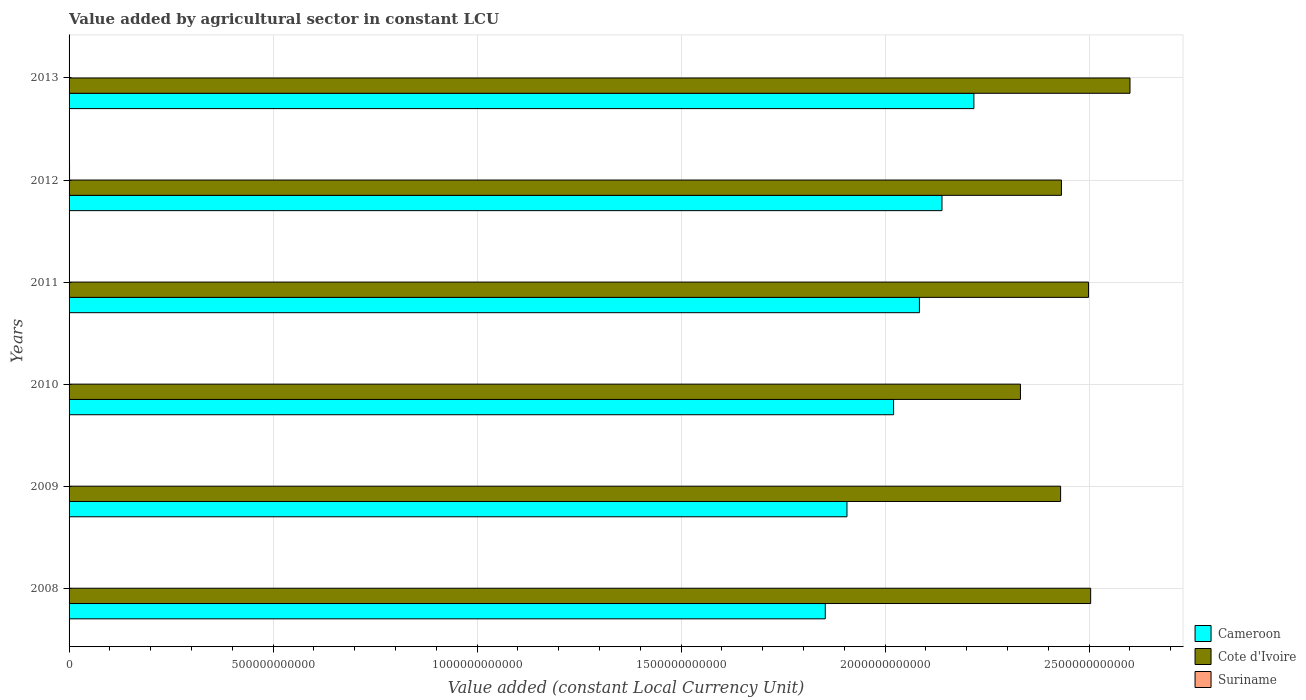How many different coloured bars are there?
Your response must be concise. 3. Are the number of bars per tick equal to the number of legend labels?
Keep it short and to the point. Yes. Are the number of bars on each tick of the Y-axis equal?
Your answer should be compact. Yes. How many bars are there on the 6th tick from the top?
Ensure brevity in your answer.  3. What is the value added by agricultural sector in Cameroon in 2012?
Offer a very short reply. 2.14e+12. Across all years, what is the maximum value added by agricultural sector in Suriname?
Ensure brevity in your answer.  1.17e+09. Across all years, what is the minimum value added by agricultural sector in Cote d'Ivoire?
Give a very brief answer. 2.33e+12. In which year was the value added by agricultural sector in Cameroon minimum?
Provide a short and direct response. 2008. What is the total value added by agricultural sector in Cameroon in the graph?
Offer a terse response. 1.22e+13. What is the difference between the value added by agricultural sector in Cameroon in 2008 and that in 2012?
Ensure brevity in your answer.  -2.86e+11. What is the difference between the value added by agricultural sector in Suriname in 2011 and the value added by agricultural sector in Cameroon in 2008?
Offer a very short reply. -1.85e+12. What is the average value added by agricultural sector in Cote d'Ivoire per year?
Keep it short and to the point. 2.47e+12. In the year 2010, what is the difference between the value added by agricultural sector in Cote d'Ivoire and value added by agricultural sector in Suriname?
Your response must be concise. 2.33e+12. In how many years, is the value added by agricultural sector in Cote d'Ivoire greater than 1800000000000 LCU?
Make the answer very short. 6. What is the ratio of the value added by agricultural sector in Suriname in 2008 to that in 2010?
Offer a terse response. 0.75. Is the value added by agricultural sector in Cameroon in 2010 less than that in 2011?
Offer a very short reply. Yes. Is the difference between the value added by agricultural sector in Cote d'Ivoire in 2010 and 2011 greater than the difference between the value added by agricultural sector in Suriname in 2010 and 2011?
Ensure brevity in your answer.  No. What is the difference between the highest and the second highest value added by agricultural sector in Cote d'Ivoire?
Ensure brevity in your answer.  9.64e+1. What is the difference between the highest and the lowest value added by agricultural sector in Cote d'Ivoire?
Your answer should be very brief. 2.68e+11. In how many years, is the value added by agricultural sector in Cameroon greater than the average value added by agricultural sector in Cameroon taken over all years?
Provide a short and direct response. 3. Is the sum of the value added by agricultural sector in Cameroon in 2010 and 2011 greater than the maximum value added by agricultural sector in Suriname across all years?
Provide a succinct answer. Yes. What does the 1st bar from the top in 2008 represents?
Your answer should be very brief. Suriname. What does the 3rd bar from the bottom in 2013 represents?
Ensure brevity in your answer.  Suriname. Is it the case that in every year, the sum of the value added by agricultural sector in Cameroon and value added by agricultural sector in Suriname is greater than the value added by agricultural sector in Cote d'Ivoire?
Your response must be concise. No. How many bars are there?
Give a very brief answer. 18. Are all the bars in the graph horizontal?
Your answer should be very brief. Yes. What is the difference between two consecutive major ticks on the X-axis?
Keep it short and to the point. 5.00e+11. Are the values on the major ticks of X-axis written in scientific E-notation?
Your answer should be very brief. No. Does the graph contain any zero values?
Offer a terse response. No. Does the graph contain grids?
Your response must be concise. Yes. How many legend labels are there?
Your answer should be compact. 3. How are the legend labels stacked?
Provide a succinct answer. Vertical. What is the title of the graph?
Keep it short and to the point. Value added by agricultural sector in constant LCU. What is the label or title of the X-axis?
Keep it short and to the point. Value added (constant Local Currency Unit). What is the Value added (constant Local Currency Unit) of Cameroon in 2008?
Your answer should be compact. 1.85e+12. What is the Value added (constant Local Currency Unit) of Cote d'Ivoire in 2008?
Provide a short and direct response. 2.50e+12. What is the Value added (constant Local Currency Unit) of Suriname in 2008?
Provide a succinct answer. 7.61e+08. What is the Value added (constant Local Currency Unit) of Cameroon in 2009?
Provide a short and direct response. 1.91e+12. What is the Value added (constant Local Currency Unit) in Cote d'Ivoire in 2009?
Your response must be concise. 2.43e+12. What is the Value added (constant Local Currency Unit) in Suriname in 2009?
Keep it short and to the point. 9.93e+08. What is the Value added (constant Local Currency Unit) of Cameroon in 2010?
Your answer should be compact. 2.02e+12. What is the Value added (constant Local Currency Unit) of Cote d'Ivoire in 2010?
Your response must be concise. 2.33e+12. What is the Value added (constant Local Currency Unit) in Suriname in 2010?
Provide a short and direct response. 1.02e+09. What is the Value added (constant Local Currency Unit) in Cameroon in 2011?
Keep it short and to the point. 2.08e+12. What is the Value added (constant Local Currency Unit) in Cote d'Ivoire in 2011?
Your answer should be very brief. 2.50e+12. What is the Value added (constant Local Currency Unit) in Suriname in 2011?
Your response must be concise. 1.06e+09. What is the Value added (constant Local Currency Unit) in Cameroon in 2012?
Your response must be concise. 2.14e+12. What is the Value added (constant Local Currency Unit) of Cote d'Ivoire in 2012?
Ensure brevity in your answer.  2.43e+12. What is the Value added (constant Local Currency Unit) of Suriname in 2012?
Offer a terse response. 1.17e+09. What is the Value added (constant Local Currency Unit) in Cameroon in 2013?
Your answer should be compact. 2.22e+12. What is the Value added (constant Local Currency Unit) of Cote d'Ivoire in 2013?
Give a very brief answer. 2.60e+12. What is the Value added (constant Local Currency Unit) of Suriname in 2013?
Ensure brevity in your answer.  1.07e+09. Across all years, what is the maximum Value added (constant Local Currency Unit) of Cameroon?
Your response must be concise. 2.22e+12. Across all years, what is the maximum Value added (constant Local Currency Unit) of Cote d'Ivoire?
Ensure brevity in your answer.  2.60e+12. Across all years, what is the maximum Value added (constant Local Currency Unit) of Suriname?
Provide a short and direct response. 1.17e+09. Across all years, what is the minimum Value added (constant Local Currency Unit) in Cameroon?
Keep it short and to the point. 1.85e+12. Across all years, what is the minimum Value added (constant Local Currency Unit) of Cote d'Ivoire?
Make the answer very short. 2.33e+12. Across all years, what is the minimum Value added (constant Local Currency Unit) of Suriname?
Give a very brief answer. 7.61e+08. What is the total Value added (constant Local Currency Unit) in Cameroon in the graph?
Offer a terse response. 1.22e+13. What is the total Value added (constant Local Currency Unit) of Cote d'Ivoire in the graph?
Ensure brevity in your answer.  1.48e+13. What is the total Value added (constant Local Currency Unit) in Suriname in the graph?
Your response must be concise. 6.08e+09. What is the difference between the Value added (constant Local Currency Unit) in Cameroon in 2008 and that in 2009?
Your answer should be very brief. -5.31e+1. What is the difference between the Value added (constant Local Currency Unit) of Cote d'Ivoire in 2008 and that in 2009?
Give a very brief answer. 7.36e+1. What is the difference between the Value added (constant Local Currency Unit) in Suriname in 2008 and that in 2009?
Give a very brief answer. -2.32e+08. What is the difference between the Value added (constant Local Currency Unit) in Cameroon in 2008 and that in 2010?
Ensure brevity in your answer.  -1.67e+11. What is the difference between the Value added (constant Local Currency Unit) in Cote d'Ivoire in 2008 and that in 2010?
Your response must be concise. 1.72e+11. What is the difference between the Value added (constant Local Currency Unit) in Suriname in 2008 and that in 2010?
Make the answer very short. -2.60e+08. What is the difference between the Value added (constant Local Currency Unit) of Cameroon in 2008 and that in 2011?
Your response must be concise. -2.31e+11. What is the difference between the Value added (constant Local Currency Unit) in Cote d'Ivoire in 2008 and that in 2011?
Give a very brief answer. 5.21e+09. What is the difference between the Value added (constant Local Currency Unit) of Suriname in 2008 and that in 2011?
Provide a succinct answer. -3.04e+08. What is the difference between the Value added (constant Local Currency Unit) in Cameroon in 2008 and that in 2012?
Ensure brevity in your answer.  -2.86e+11. What is the difference between the Value added (constant Local Currency Unit) of Cote d'Ivoire in 2008 and that in 2012?
Give a very brief answer. 7.16e+1. What is the difference between the Value added (constant Local Currency Unit) in Suriname in 2008 and that in 2012?
Offer a very short reply. -4.12e+08. What is the difference between the Value added (constant Local Currency Unit) in Cameroon in 2008 and that in 2013?
Keep it short and to the point. -3.64e+11. What is the difference between the Value added (constant Local Currency Unit) of Cote d'Ivoire in 2008 and that in 2013?
Your answer should be compact. -9.64e+1. What is the difference between the Value added (constant Local Currency Unit) in Suriname in 2008 and that in 2013?
Give a very brief answer. -3.08e+08. What is the difference between the Value added (constant Local Currency Unit) of Cameroon in 2009 and that in 2010?
Offer a terse response. -1.14e+11. What is the difference between the Value added (constant Local Currency Unit) in Cote d'Ivoire in 2009 and that in 2010?
Provide a short and direct response. 9.84e+1. What is the difference between the Value added (constant Local Currency Unit) in Suriname in 2009 and that in 2010?
Your answer should be very brief. -2.80e+07. What is the difference between the Value added (constant Local Currency Unit) in Cameroon in 2009 and that in 2011?
Keep it short and to the point. -1.78e+11. What is the difference between the Value added (constant Local Currency Unit) of Cote d'Ivoire in 2009 and that in 2011?
Make the answer very short. -6.84e+1. What is the difference between the Value added (constant Local Currency Unit) of Suriname in 2009 and that in 2011?
Offer a very short reply. -7.20e+07. What is the difference between the Value added (constant Local Currency Unit) of Cameroon in 2009 and that in 2012?
Offer a terse response. -2.33e+11. What is the difference between the Value added (constant Local Currency Unit) of Cote d'Ivoire in 2009 and that in 2012?
Give a very brief answer. -2.03e+09. What is the difference between the Value added (constant Local Currency Unit) in Suriname in 2009 and that in 2012?
Your answer should be very brief. -1.80e+08. What is the difference between the Value added (constant Local Currency Unit) in Cameroon in 2009 and that in 2013?
Give a very brief answer. -3.11e+11. What is the difference between the Value added (constant Local Currency Unit) in Cote d'Ivoire in 2009 and that in 2013?
Your answer should be compact. -1.70e+11. What is the difference between the Value added (constant Local Currency Unit) in Suriname in 2009 and that in 2013?
Your answer should be compact. -7.60e+07. What is the difference between the Value added (constant Local Currency Unit) of Cameroon in 2010 and that in 2011?
Offer a very short reply. -6.33e+1. What is the difference between the Value added (constant Local Currency Unit) in Cote d'Ivoire in 2010 and that in 2011?
Make the answer very short. -1.67e+11. What is the difference between the Value added (constant Local Currency Unit) in Suriname in 2010 and that in 2011?
Make the answer very short. -4.40e+07. What is the difference between the Value added (constant Local Currency Unit) of Cameroon in 2010 and that in 2012?
Keep it short and to the point. -1.19e+11. What is the difference between the Value added (constant Local Currency Unit) in Cote d'Ivoire in 2010 and that in 2012?
Offer a terse response. -1.00e+11. What is the difference between the Value added (constant Local Currency Unit) of Suriname in 2010 and that in 2012?
Provide a succinct answer. -1.52e+08. What is the difference between the Value added (constant Local Currency Unit) of Cameroon in 2010 and that in 2013?
Give a very brief answer. -1.97e+11. What is the difference between the Value added (constant Local Currency Unit) in Cote d'Ivoire in 2010 and that in 2013?
Keep it short and to the point. -2.68e+11. What is the difference between the Value added (constant Local Currency Unit) of Suriname in 2010 and that in 2013?
Keep it short and to the point. -4.80e+07. What is the difference between the Value added (constant Local Currency Unit) in Cameroon in 2011 and that in 2012?
Your answer should be very brief. -5.53e+1. What is the difference between the Value added (constant Local Currency Unit) of Cote d'Ivoire in 2011 and that in 2012?
Your response must be concise. 6.64e+1. What is the difference between the Value added (constant Local Currency Unit) in Suriname in 2011 and that in 2012?
Give a very brief answer. -1.08e+08. What is the difference between the Value added (constant Local Currency Unit) in Cameroon in 2011 and that in 2013?
Ensure brevity in your answer.  -1.33e+11. What is the difference between the Value added (constant Local Currency Unit) of Cote d'Ivoire in 2011 and that in 2013?
Offer a terse response. -1.02e+11. What is the difference between the Value added (constant Local Currency Unit) in Cameroon in 2012 and that in 2013?
Provide a short and direct response. -7.82e+1. What is the difference between the Value added (constant Local Currency Unit) of Cote d'Ivoire in 2012 and that in 2013?
Provide a short and direct response. -1.68e+11. What is the difference between the Value added (constant Local Currency Unit) in Suriname in 2012 and that in 2013?
Offer a terse response. 1.04e+08. What is the difference between the Value added (constant Local Currency Unit) of Cameroon in 2008 and the Value added (constant Local Currency Unit) of Cote d'Ivoire in 2009?
Your response must be concise. -5.77e+11. What is the difference between the Value added (constant Local Currency Unit) in Cameroon in 2008 and the Value added (constant Local Currency Unit) in Suriname in 2009?
Provide a short and direct response. 1.85e+12. What is the difference between the Value added (constant Local Currency Unit) of Cote d'Ivoire in 2008 and the Value added (constant Local Currency Unit) of Suriname in 2009?
Keep it short and to the point. 2.50e+12. What is the difference between the Value added (constant Local Currency Unit) in Cameroon in 2008 and the Value added (constant Local Currency Unit) in Cote d'Ivoire in 2010?
Make the answer very short. -4.78e+11. What is the difference between the Value added (constant Local Currency Unit) of Cameroon in 2008 and the Value added (constant Local Currency Unit) of Suriname in 2010?
Offer a terse response. 1.85e+12. What is the difference between the Value added (constant Local Currency Unit) of Cote d'Ivoire in 2008 and the Value added (constant Local Currency Unit) of Suriname in 2010?
Your response must be concise. 2.50e+12. What is the difference between the Value added (constant Local Currency Unit) of Cameroon in 2008 and the Value added (constant Local Currency Unit) of Cote d'Ivoire in 2011?
Your answer should be very brief. -6.45e+11. What is the difference between the Value added (constant Local Currency Unit) in Cameroon in 2008 and the Value added (constant Local Currency Unit) in Suriname in 2011?
Your response must be concise. 1.85e+12. What is the difference between the Value added (constant Local Currency Unit) in Cote d'Ivoire in 2008 and the Value added (constant Local Currency Unit) in Suriname in 2011?
Your answer should be compact. 2.50e+12. What is the difference between the Value added (constant Local Currency Unit) in Cameroon in 2008 and the Value added (constant Local Currency Unit) in Cote d'Ivoire in 2012?
Your answer should be compact. -5.79e+11. What is the difference between the Value added (constant Local Currency Unit) of Cameroon in 2008 and the Value added (constant Local Currency Unit) of Suriname in 2012?
Make the answer very short. 1.85e+12. What is the difference between the Value added (constant Local Currency Unit) in Cote d'Ivoire in 2008 and the Value added (constant Local Currency Unit) in Suriname in 2012?
Your response must be concise. 2.50e+12. What is the difference between the Value added (constant Local Currency Unit) of Cameroon in 2008 and the Value added (constant Local Currency Unit) of Cote d'Ivoire in 2013?
Give a very brief answer. -7.47e+11. What is the difference between the Value added (constant Local Currency Unit) of Cameroon in 2008 and the Value added (constant Local Currency Unit) of Suriname in 2013?
Provide a succinct answer. 1.85e+12. What is the difference between the Value added (constant Local Currency Unit) in Cote d'Ivoire in 2008 and the Value added (constant Local Currency Unit) in Suriname in 2013?
Keep it short and to the point. 2.50e+12. What is the difference between the Value added (constant Local Currency Unit) of Cameroon in 2009 and the Value added (constant Local Currency Unit) of Cote d'Ivoire in 2010?
Keep it short and to the point. -4.25e+11. What is the difference between the Value added (constant Local Currency Unit) in Cameroon in 2009 and the Value added (constant Local Currency Unit) in Suriname in 2010?
Ensure brevity in your answer.  1.91e+12. What is the difference between the Value added (constant Local Currency Unit) of Cote d'Ivoire in 2009 and the Value added (constant Local Currency Unit) of Suriname in 2010?
Provide a short and direct response. 2.43e+12. What is the difference between the Value added (constant Local Currency Unit) in Cameroon in 2009 and the Value added (constant Local Currency Unit) in Cote d'Ivoire in 2011?
Your answer should be compact. -5.92e+11. What is the difference between the Value added (constant Local Currency Unit) of Cameroon in 2009 and the Value added (constant Local Currency Unit) of Suriname in 2011?
Your answer should be very brief. 1.91e+12. What is the difference between the Value added (constant Local Currency Unit) in Cote d'Ivoire in 2009 and the Value added (constant Local Currency Unit) in Suriname in 2011?
Provide a succinct answer. 2.43e+12. What is the difference between the Value added (constant Local Currency Unit) in Cameroon in 2009 and the Value added (constant Local Currency Unit) in Cote d'Ivoire in 2012?
Your answer should be very brief. -5.26e+11. What is the difference between the Value added (constant Local Currency Unit) in Cameroon in 2009 and the Value added (constant Local Currency Unit) in Suriname in 2012?
Your answer should be compact. 1.91e+12. What is the difference between the Value added (constant Local Currency Unit) of Cote d'Ivoire in 2009 and the Value added (constant Local Currency Unit) of Suriname in 2012?
Provide a short and direct response. 2.43e+12. What is the difference between the Value added (constant Local Currency Unit) of Cameroon in 2009 and the Value added (constant Local Currency Unit) of Cote d'Ivoire in 2013?
Offer a very short reply. -6.94e+11. What is the difference between the Value added (constant Local Currency Unit) of Cameroon in 2009 and the Value added (constant Local Currency Unit) of Suriname in 2013?
Your answer should be compact. 1.91e+12. What is the difference between the Value added (constant Local Currency Unit) in Cote d'Ivoire in 2009 and the Value added (constant Local Currency Unit) in Suriname in 2013?
Offer a very short reply. 2.43e+12. What is the difference between the Value added (constant Local Currency Unit) in Cameroon in 2010 and the Value added (constant Local Currency Unit) in Cote d'Ivoire in 2011?
Ensure brevity in your answer.  -4.78e+11. What is the difference between the Value added (constant Local Currency Unit) in Cameroon in 2010 and the Value added (constant Local Currency Unit) in Suriname in 2011?
Make the answer very short. 2.02e+12. What is the difference between the Value added (constant Local Currency Unit) in Cote d'Ivoire in 2010 and the Value added (constant Local Currency Unit) in Suriname in 2011?
Provide a succinct answer. 2.33e+12. What is the difference between the Value added (constant Local Currency Unit) in Cameroon in 2010 and the Value added (constant Local Currency Unit) in Cote d'Ivoire in 2012?
Offer a terse response. -4.11e+11. What is the difference between the Value added (constant Local Currency Unit) in Cameroon in 2010 and the Value added (constant Local Currency Unit) in Suriname in 2012?
Give a very brief answer. 2.02e+12. What is the difference between the Value added (constant Local Currency Unit) in Cote d'Ivoire in 2010 and the Value added (constant Local Currency Unit) in Suriname in 2012?
Offer a very short reply. 2.33e+12. What is the difference between the Value added (constant Local Currency Unit) in Cameroon in 2010 and the Value added (constant Local Currency Unit) in Cote d'Ivoire in 2013?
Ensure brevity in your answer.  -5.79e+11. What is the difference between the Value added (constant Local Currency Unit) in Cameroon in 2010 and the Value added (constant Local Currency Unit) in Suriname in 2013?
Your answer should be compact. 2.02e+12. What is the difference between the Value added (constant Local Currency Unit) of Cote d'Ivoire in 2010 and the Value added (constant Local Currency Unit) of Suriname in 2013?
Your answer should be compact. 2.33e+12. What is the difference between the Value added (constant Local Currency Unit) in Cameroon in 2011 and the Value added (constant Local Currency Unit) in Cote d'Ivoire in 2012?
Your answer should be compact. -3.48e+11. What is the difference between the Value added (constant Local Currency Unit) of Cameroon in 2011 and the Value added (constant Local Currency Unit) of Suriname in 2012?
Provide a short and direct response. 2.08e+12. What is the difference between the Value added (constant Local Currency Unit) of Cote d'Ivoire in 2011 and the Value added (constant Local Currency Unit) of Suriname in 2012?
Give a very brief answer. 2.50e+12. What is the difference between the Value added (constant Local Currency Unit) in Cameroon in 2011 and the Value added (constant Local Currency Unit) in Cote d'Ivoire in 2013?
Provide a succinct answer. -5.16e+11. What is the difference between the Value added (constant Local Currency Unit) in Cameroon in 2011 and the Value added (constant Local Currency Unit) in Suriname in 2013?
Your answer should be compact. 2.08e+12. What is the difference between the Value added (constant Local Currency Unit) in Cote d'Ivoire in 2011 and the Value added (constant Local Currency Unit) in Suriname in 2013?
Your answer should be very brief. 2.50e+12. What is the difference between the Value added (constant Local Currency Unit) of Cameroon in 2012 and the Value added (constant Local Currency Unit) of Cote d'Ivoire in 2013?
Offer a terse response. -4.61e+11. What is the difference between the Value added (constant Local Currency Unit) of Cameroon in 2012 and the Value added (constant Local Currency Unit) of Suriname in 2013?
Your answer should be compact. 2.14e+12. What is the difference between the Value added (constant Local Currency Unit) of Cote d'Ivoire in 2012 and the Value added (constant Local Currency Unit) of Suriname in 2013?
Provide a short and direct response. 2.43e+12. What is the average Value added (constant Local Currency Unit) of Cameroon per year?
Offer a terse response. 2.04e+12. What is the average Value added (constant Local Currency Unit) of Cote d'Ivoire per year?
Your answer should be compact. 2.47e+12. What is the average Value added (constant Local Currency Unit) in Suriname per year?
Offer a terse response. 1.01e+09. In the year 2008, what is the difference between the Value added (constant Local Currency Unit) in Cameroon and Value added (constant Local Currency Unit) in Cote d'Ivoire?
Provide a succinct answer. -6.50e+11. In the year 2008, what is the difference between the Value added (constant Local Currency Unit) of Cameroon and Value added (constant Local Currency Unit) of Suriname?
Give a very brief answer. 1.85e+12. In the year 2008, what is the difference between the Value added (constant Local Currency Unit) of Cote d'Ivoire and Value added (constant Local Currency Unit) of Suriname?
Offer a terse response. 2.50e+12. In the year 2009, what is the difference between the Value added (constant Local Currency Unit) in Cameroon and Value added (constant Local Currency Unit) in Cote d'Ivoire?
Provide a succinct answer. -5.24e+11. In the year 2009, what is the difference between the Value added (constant Local Currency Unit) in Cameroon and Value added (constant Local Currency Unit) in Suriname?
Provide a short and direct response. 1.91e+12. In the year 2009, what is the difference between the Value added (constant Local Currency Unit) in Cote d'Ivoire and Value added (constant Local Currency Unit) in Suriname?
Provide a short and direct response. 2.43e+12. In the year 2010, what is the difference between the Value added (constant Local Currency Unit) in Cameroon and Value added (constant Local Currency Unit) in Cote d'Ivoire?
Your answer should be compact. -3.11e+11. In the year 2010, what is the difference between the Value added (constant Local Currency Unit) of Cameroon and Value added (constant Local Currency Unit) of Suriname?
Your answer should be very brief. 2.02e+12. In the year 2010, what is the difference between the Value added (constant Local Currency Unit) of Cote d'Ivoire and Value added (constant Local Currency Unit) of Suriname?
Provide a short and direct response. 2.33e+12. In the year 2011, what is the difference between the Value added (constant Local Currency Unit) of Cameroon and Value added (constant Local Currency Unit) of Cote d'Ivoire?
Provide a succinct answer. -4.14e+11. In the year 2011, what is the difference between the Value added (constant Local Currency Unit) of Cameroon and Value added (constant Local Currency Unit) of Suriname?
Your answer should be very brief. 2.08e+12. In the year 2011, what is the difference between the Value added (constant Local Currency Unit) of Cote d'Ivoire and Value added (constant Local Currency Unit) of Suriname?
Your response must be concise. 2.50e+12. In the year 2012, what is the difference between the Value added (constant Local Currency Unit) of Cameroon and Value added (constant Local Currency Unit) of Cote d'Ivoire?
Offer a terse response. -2.93e+11. In the year 2012, what is the difference between the Value added (constant Local Currency Unit) in Cameroon and Value added (constant Local Currency Unit) in Suriname?
Your answer should be very brief. 2.14e+12. In the year 2012, what is the difference between the Value added (constant Local Currency Unit) of Cote d'Ivoire and Value added (constant Local Currency Unit) of Suriname?
Offer a terse response. 2.43e+12. In the year 2013, what is the difference between the Value added (constant Local Currency Unit) of Cameroon and Value added (constant Local Currency Unit) of Cote d'Ivoire?
Your response must be concise. -3.83e+11. In the year 2013, what is the difference between the Value added (constant Local Currency Unit) in Cameroon and Value added (constant Local Currency Unit) in Suriname?
Your answer should be very brief. 2.22e+12. In the year 2013, what is the difference between the Value added (constant Local Currency Unit) of Cote d'Ivoire and Value added (constant Local Currency Unit) of Suriname?
Make the answer very short. 2.60e+12. What is the ratio of the Value added (constant Local Currency Unit) of Cameroon in 2008 to that in 2009?
Keep it short and to the point. 0.97. What is the ratio of the Value added (constant Local Currency Unit) in Cote d'Ivoire in 2008 to that in 2009?
Ensure brevity in your answer.  1.03. What is the ratio of the Value added (constant Local Currency Unit) in Suriname in 2008 to that in 2009?
Offer a terse response. 0.77. What is the ratio of the Value added (constant Local Currency Unit) of Cameroon in 2008 to that in 2010?
Provide a short and direct response. 0.92. What is the ratio of the Value added (constant Local Currency Unit) in Cote d'Ivoire in 2008 to that in 2010?
Your answer should be very brief. 1.07. What is the ratio of the Value added (constant Local Currency Unit) in Suriname in 2008 to that in 2010?
Offer a terse response. 0.75. What is the ratio of the Value added (constant Local Currency Unit) in Cameroon in 2008 to that in 2011?
Keep it short and to the point. 0.89. What is the ratio of the Value added (constant Local Currency Unit) of Suriname in 2008 to that in 2011?
Give a very brief answer. 0.71. What is the ratio of the Value added (constant Local Currency Unit) in Cameroon in 2008 to that in 2012?
Make the answer very short. 0.87. What is the ratio of the Value added (constant Local Currency Unit) in Cote d'Ivoire in 2008 to that in 2012?
Provide a succinct answer. 1.03. What is the ratio of the Value added (constant Local Currency Unit) in Suriname in 2008 to that in 2012?
Your response must be concise. 0.65. What is the ratio of the Value added (constant Local Currency Unit) of Cameroon in 2008 to that in 2013?
Give a very brief answer. 0.84. What is the ratio of the Value added (constant Local Currency Unit) in Cote d'Ivoire in 2008 to that in 2013?
Your response must be concise. 0.96. What is the ratio of the Value added (constant Local Currency Unit) in Suriname in 2008 to that in 2013?
Offer a terse response. 0.71. What is the ratio of the Value added (constant Local Currency Unit) of Cameroon in 2009 to that in 2010?
Offer a very short reply. 0.94. What is the ratio of the Value added (constant Local Currency Unit) in Cote d'Ivoire in 2009 to that in 2010?
Give a very brief answer. 1.04. What is the ratio of the Value added (constant Local Currency Unit) in Suriname in 2009 to that in 2010?
Provide a short and direct response. 0.97. What is the ratio of the Value added (constant Local Currency Unit) in Cameroon in 2009 to that in 2011?
Make the answer very short. 0.91. What is the ratio of the Value added (constant Local Currency Unit) in Cote d'Ivoire in 2009 to that in 2011?
Your answer should be very brief. 0.97. What is the ratio of the Value added (constant Local Currency Unit) in Suriname in 2009 to that in 2011?
Provide a succinct answer. 0.93. What is the ratio of the Value added (constant Local Currency Unit) of Cameroon in 2009 to that in 2012?
Your response must be concise. 0.89. What is the ratio of the Value added (constant Local Currency Unit) of Suriname in 2009 to that in 2012?
Your response must be concise. 0.85. What is the ratio of the Value added (constant Local Currency Unit) in Cameroon in 2009 to that in 2013?
Keep it short and to the point. 0.86. What is the ratio of the Value added (constant Local Currency Unit) in Cote d'Ivoire in 2009 to that in 2013?
Offer a very short reply. 0.93. What is the ratio of the Value added (constant Local Currency Unit) of Suriname in 2009 to that in 2013?
Offer a terse response. 0.93. What is the ratio of the Value added (constant Local Currency Unit) in Cameroon in 2010 to that in 2011?
Give a very brief answer. 0.97. What is the ratio of the Value added (constant Local Currency Unit) in Cote d'Ivoire in 2010 to that in 2011?
Ensure brevity in your answer.  0.93. What is the ratio of the Value added (constant Local Currency Unit) in Suriname in 2010 to that in 2011?
Offer a terse response. 0.96. What is the ratio of the Value added (constant Local Currency Unit) of Cameroon in 2010 to that in 2012?
Provide a short and direct response. 0.94. What is the ratio of the Value added (constant Local Currency Unit) in Cote d'Ivoire in 2010 to that in 2012?
Provide a succinct answer. 0.96. What is the ratio of the Value added (constant Local Currency Unit) of Suriname in 2010 to that in 2012?
Your response must be concise. 0.87. What is the ratio of the Value added (constant Local Currency Unit) of Cameroon in 2010 to that in 2013?
Provide a short and direct response. 0.91. What is the ratio of the Value added (constant Local Currency Unit) in Cote d'Ivoire in 2010 to that in 2013?
Your answer should be very brief. 0.9. What is the ratio of the Value added (constant Local Currency Unit) in Suriname in 2010 to that in 2013?
Offer a terse response. 0.96. What is the ratio of the Value added (constant Local Currency Unit) in Cameroon in 2011 to that in 2012?
Your answer should be compact. 0.97. What is the ratio of the Value added (constant Local Currency Unit) in Cote d'Ivoire in 2011 to that in 2012?
Your answer should be very brief. 1.03. What is the ratio of the Value added (constant Local Currency Unit) in Suriname in 2011 to that in 2012?
Give a very brief answer. 0.91. What is the ratio of the Value added (constant Local Currency Unit) of Cameroon in 2011 to that in 2013?
Provide a succinct answer. 0.94. What is the ratio of the Value added (constant Local Currency Unit) of Cote d'Ivoire in 2011 to that in 2013?
Your response must be concise. 0.96. What is the ratio of the Value added (constant Local Currency Unit) in Suriname in 2011 to that in 2013?
Provide a succinct answer. 1. What is the ratio of the Value added (constant Local Currency Unit) of Cameroon in 2012 to that in 2013?
Offer a very short reply. 0.96. What is the ratio of the Value added (constant Local Currency Unit) of Cote d'Ivoire in 2012 to that in 2013?
Offer a terse response. 0.94. What is the ratio of the Value added (constant Local Currency Unit) in Suriname in 2012 to that in 2013?
Offer a very short reply. 1.1. What is the difference between the highest and the second highest Value added (constant Local Currency Unit) of Cameroon?
Keep it short and to the point. 7.82e+1. What is the difference between the highest and the second highest Value added (constant Local Currency Unit) in Cote d'Ivoire?
Offer a very short reply. 9.64e+1. What is the difference between the highest and the second highest Value added (constant Local Currency Unit) in Suriname?
Offer a very short reply. 1.04e+08. What is the difference between the highest and the lowest Value added (constant Local Currency Unit) of Cameroon?
Offer a terse response. 3.64e+11. What is the difference between the highest and the lowest Value added (constant Local Currency Unit) in Cote d'Ivoire?
Your answer should be very brief. 2.68e+11. What is the difference between the highest and the lowest Value added (constant Local Currency Unit) of Suriname?
Your answer should be compact. 4.12e+08. 